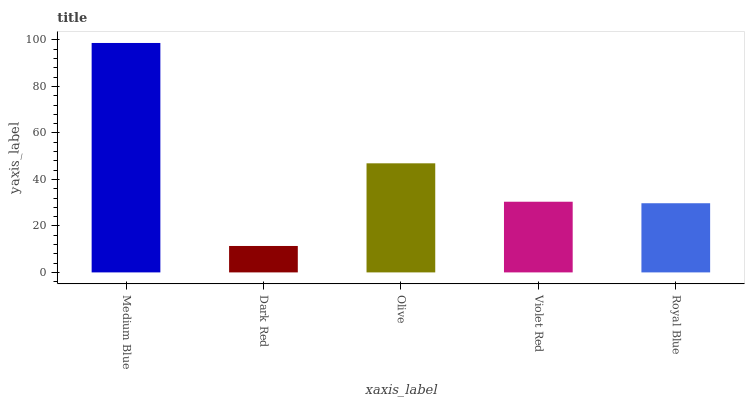Is Dark Red the minimum?
Answer yes or no. Yes. Is Medium Blue the maximum?
Answer yes or no. Yes. Is Olive the minimum?
Answer yes or no. No. Is Olive the maximum?
Answer yes or no. No. Is Olive greater than Dark Red?
Answer yes or no. Yes. Is Dark Red less than Olive?
Answer yes or no. Yes. Is Dark Red greater than Olive?
Answer yes or no. No. Is Olive less than Dark Red?
Answer yes or no. No. Is Violet Red the high median?
Answer yes or no. Yes. Is Violet Red the low median?
Answer yes or no. Yes. Is Medium Blue the high median?
Answer yes or no. No. Is Medium Blue the low median?
Answer yes or no. No. 